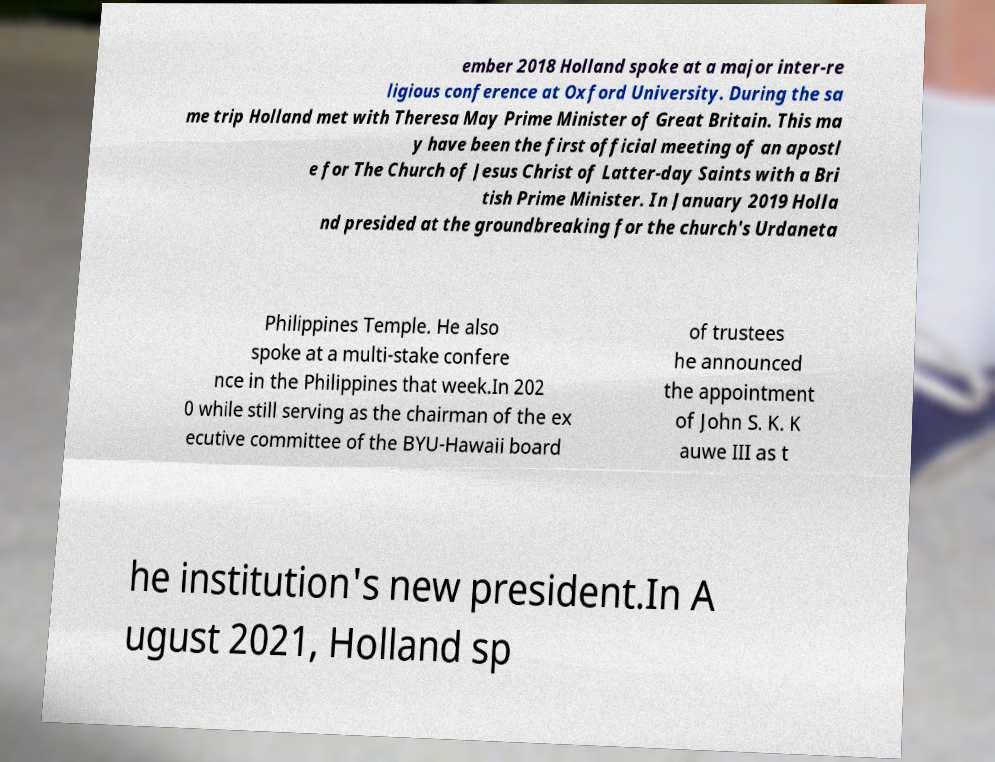Can you read and provide the text displayed in the image?This photo seems to have some interesting text. Can you extract and type it out for me? ember 2018 Holland spoke at a major inter-re ligious conference at Oxford University. During the sa me trip Holland met with Theresa May Prime Minister of Great Britain. This ma y have been the first official meeting of an apostl e for The Church of Jesus Christ of Latter-day Saints with a Bri tish Prime Minister. In January 2019 Holla nd presided at the groundbreaking for the church's Urdaneta Philippines Temple. He also spoke at a multi-stake confere nce in the Philippines that week.In 202 0 while still serving as the chairman of the ex ecutive committee of the BYU-Hawaii board of trustees he announced the appointment of John S. K. K auwe III as t he institution's new president.In A ugust 2021, Holland sp 